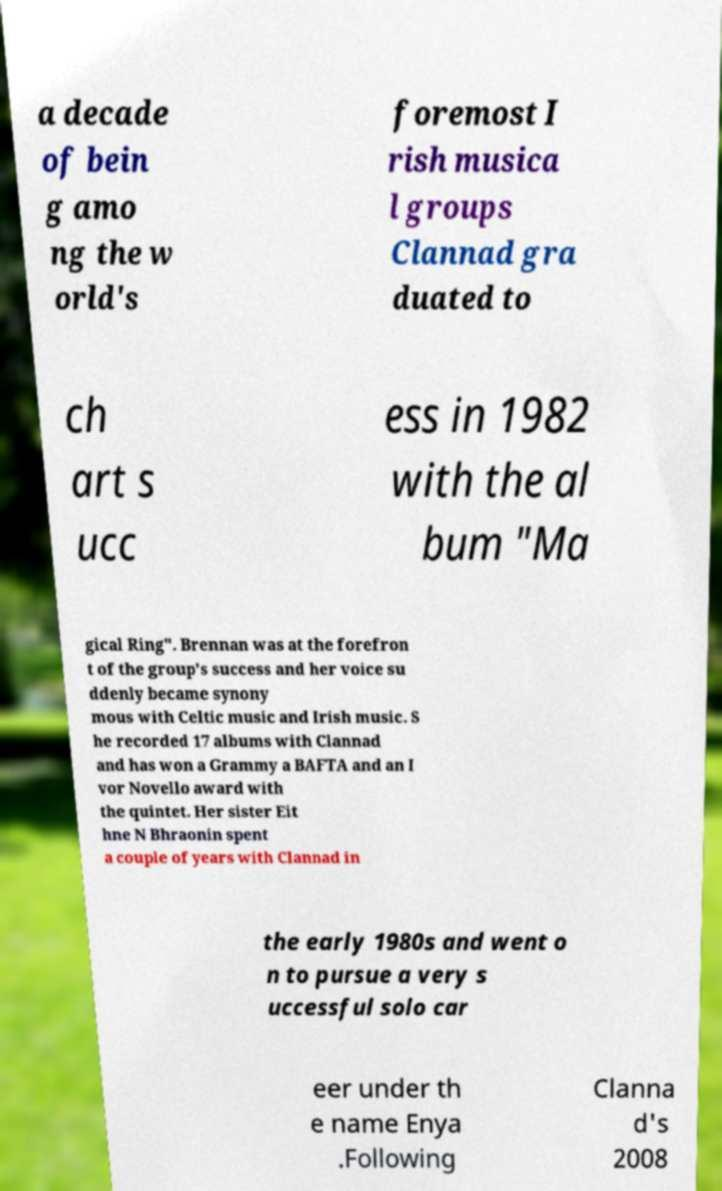There's text embedded in this image that I need extracted. Can you transcribe it verbatim? a decade of bein g amo ng the w orld's foremost I rish musica l groups Clannad gra duated to ch art s ucc ess in 1982 with the al bum "Ma gical Ring". Brennan was at the forefron t of the group's success and her voice su ddenly became synony mous with Celtic music and Irish music. S he recorded 17 albums with Clannad and has won a Grammy a BAFTA and an I vor Novello award with the quintet. Her sister Eit hne N Bhraonin spent a couple of years with Clannad in the early 1980s and went o n to pursue a very s uccessful solo car eer under th e name Enya .Following Clanna d's 2008 